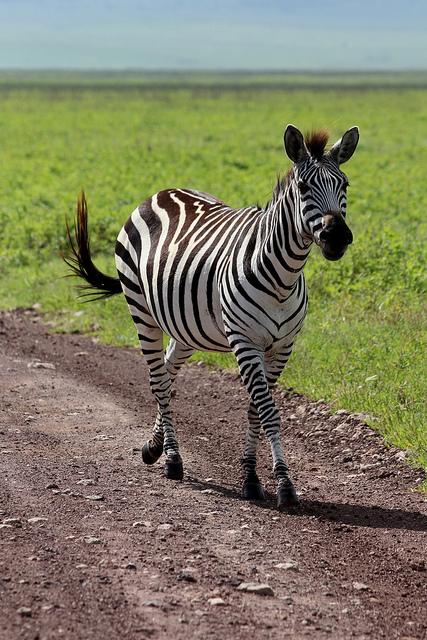Is the zebra walking or sitting?
Short answer required. Walking. Is the zebra in a hurry?
Be succinct. No. How many animals are shown?
Keep it brief. 1. Is the ground wet?
Be succinct. No. What is in the background?
Keep it brief. Grass. Is the zebra's tail hanging down?
Answer briefly. No. 